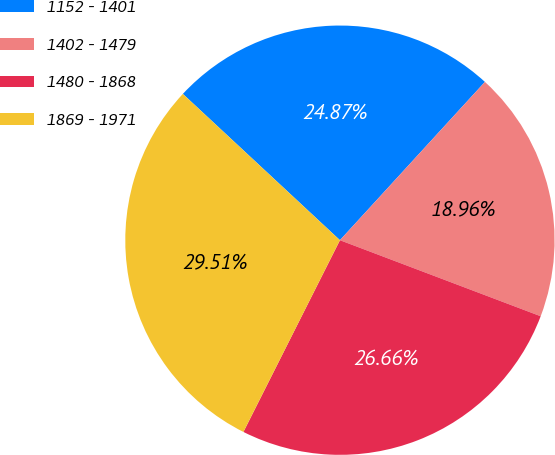Convert chart. <chart><loc_0><loc_0><loc_500><loc_500><pie_chart><fcel>1152 - 1401<fcel>1402 - 1479<fcel>1480 - 1868<fcel>1869 - 1971<nl><fcel>24.87%<fcel>18.96%<fcel>26.66%<fcel>29.51%<nl></chart> 